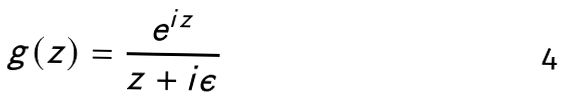Convert formula to latex. <formula><loc_0><loc_0><loc_500><loc_500>g ( z ) = \frac { e ^ { i z } } { z + i \epsilon }</formula> 